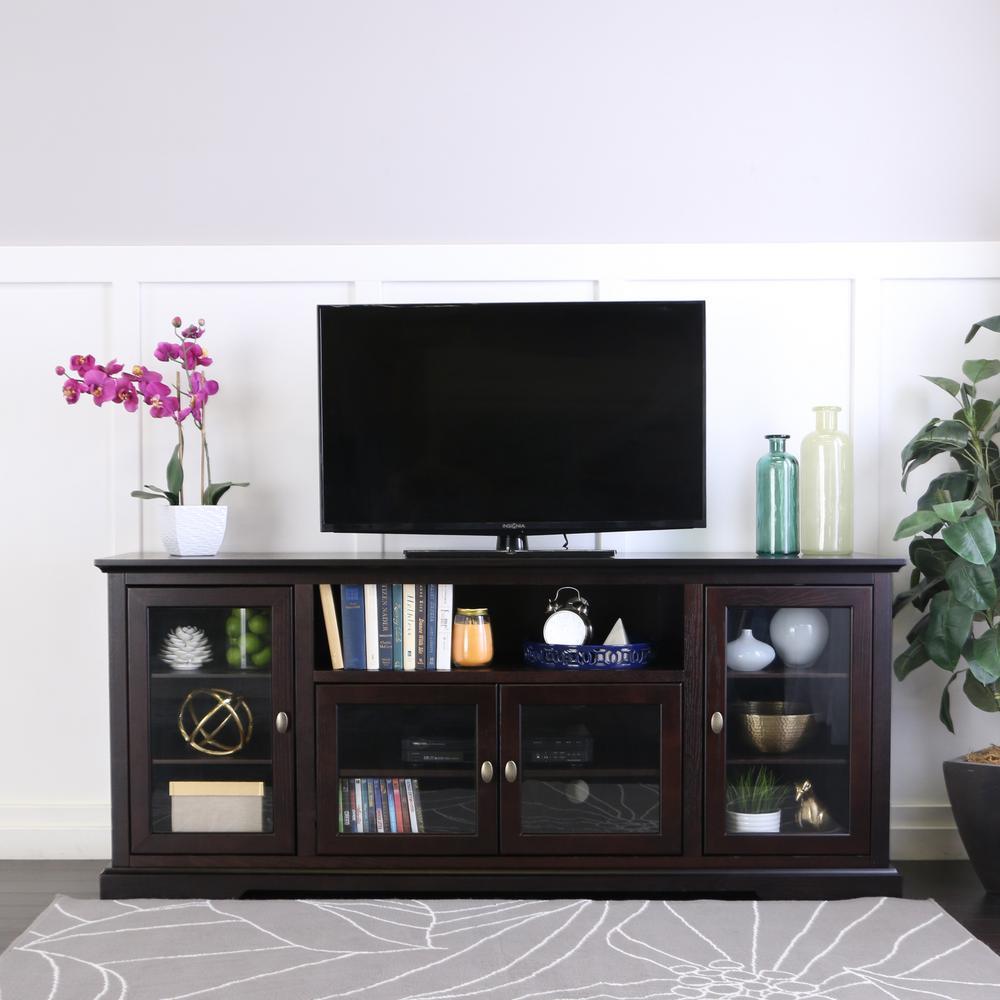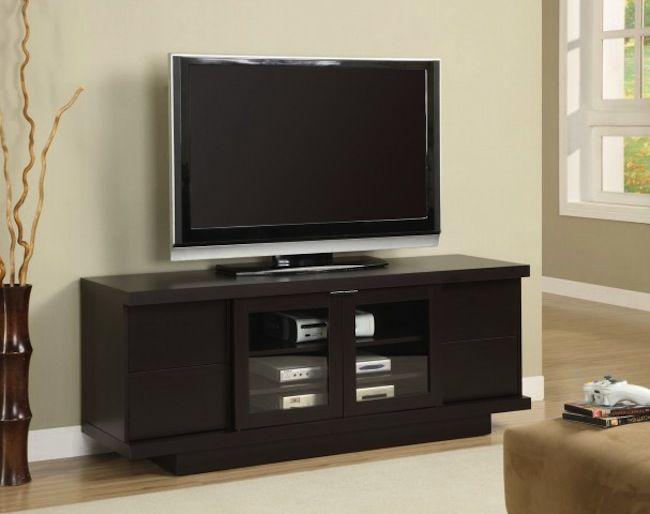The first image is the image on the left, the second image is the image on the right. Analyze the images presented: Is the assertion "A flat screen television is sitting against a wall on a low wooden cabinet that has four glass-fronted doors." valid? Answer yes or no. No. The first image is the image on the left, the second image is the image on the right. Assess this claim about the two images: "The TV stands on the left and right are similar styles, with the same dark wood and approximately the same configuration of compartments.". Correct or not? Answer yes or no. Yes. 